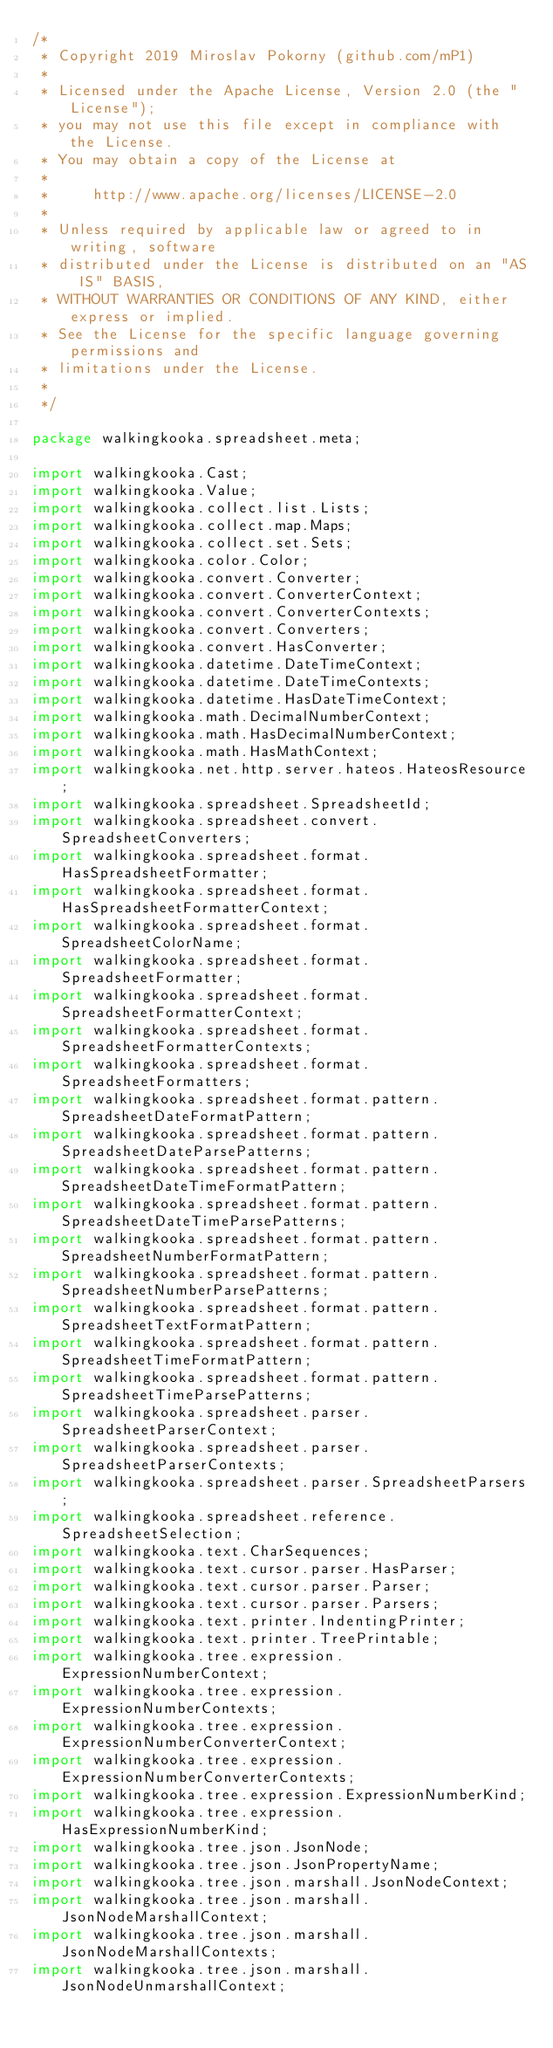<code> <loc_0><loc_0><loc_500><loc_500><_Java_>/*
 * Copyright 2019 Miroslav Pokorny (github.com/mP1)
 *
 * Licensed under the Apache License, Version 2.0 (the "License");
 * you may not use this file except in compliance with the License.
 * You may obtain a copy of the License at
 *
 *     http://www.apache.org/licenses/LICENSE-2.0
 *
 * Unless required by applicable law or agreed to in writing, software
 * distributed under the License is distributed on an "AS IS" BASIS,
 * WITHOUT WARRANTIES OR CONDITIONS OF ANY KIND, either express or implied.
 * See the License for the specific language governing permissions and
 * limitations under the License.
 *
 */

package walkingkooka.spreadsheet.meta;

import walkingkooka.Cast;
import walkingkooka.Value;
import walkingkooka.collect.list.Lists;
import walkingkooka.collect.map.Maps;
import walkingkooka.collect.set.Sets;
import walkingkooka.color.Color;
import walkingkooka.convert.Converter;
import walkingkooka.convert.ConverterContext;
import walkingkooka.convert.ConverterContexts;
import walkingkooka.convert.Converters;
import walkingkooka.convert.HasConverter;
import walkingkooka.datetime.DateTimeContext;
import walkingkooka.datetime.DateTimeContexts;
import walkingkooka.datetime.HasDateTimeContext;
import walkingkooka.math.DecimalNumberContext;
import walkingkooka.math.HasDecimalNumberContext;
import walkingkooka.math.HasMathContext;
import walkingkooka.net.http.server.hateos.HateosResource;
import walkingkooka.spreadsheet.SpreadsheetId;
import walkingkooka.spreadsheet.convert.SpreadsheetConverters;
import walkingkooka.spreadsheet.format.HasSpreadsheetFormatter;
import walkingkooka.spreadsheet.format.HasSpreadsheetFormatterContext;
import walkingkooka.spreadsheet.format.SpreadsheetColorName;
import walkingkooka.spreadsheet.format.SpreadsheetFormatter;
import walkingkooka.spreadsheet.format.SpreadsheetFormatterContext;
import walkingkooka.spreadsheet.format.SpreadsheetFormatterContexts;
import walkingkooka.spreadsheet.format.SpreadsheetFormatters;
import walkingkooka.spreadsheet.format.pattern.SpreadsheetDateFormatPattern;
import walkingkooka.spreadsheet.format.pattern.SpreadsheetDateParsePatterns;
import walkingkooka.spreadsheet.format.pattern.SpreadsheetDateTimeFormatPattern;
import walkingkooka.spreadsheet.format.pattern.SpreadsheetDateTimeParsePatterns;
import walkingkooka.spreadsheet.format.pattern.SpreadsheetNumberFormatPattern;
import walkingkooka.spreadsheet.format.pattern.SpreadsheetNumberParsePatterns;
import walkingkooka.spreadsheet.format.pattern.SpreadsheetTextFormatPattern;
import walkingkooka.spreadsheet.format.pattern.SpreadsheetTimeFormatPattern;
import walkingkooka.spreadsheet.format.pattern.SpreadsheetTimeParsePatterns;
import walkingkooka.spreadsheet.parser.SpreadsheetParserContext;
import walkingkooka.spreadsheet.parser.SpreadsheetParserContexts;
import walkingkooka.spreadsheet.parser.SpreadsheetParsers;
import walkingkooka.spreadsheet.reference.SpreadsheetSelection;
import walkingkooka.text.CharSequences;
import walkingkooka.text.cursor.parser.HasParser;
import walkingkooka.text.cursor.parser.Parser;
import walkingkooka.text.cursor.parser.Parsers;
import walkingkooka.text.printer.IndentingPrinter;
import walkingkooka.text.printer.TreePrintable;
import walkingkooka.tree.expression.ExpressionNumberContext;
import walkingkooka.tree.expression.ExpressionNumberContexts;
import walkingkooka.tree.expression.ExpressionNumberConverterContext;
import walkingkooka.tree.expression.ExpressionNumberConverterContexts;
import walkingkooka.tree.expression.ExpressionNumberKind;
import walkingkooka.tree.expression.HasExpressionNumberKind;
import walkingkooka.tree.json.JsonNode;
import walkingkooka.tree.json.JsonPropertyName;
import walkingkooka.tree.json.marshall.JsonNodeContext;
import walkingkooka.tree.json.marshall.JsonNodeMarshallContext;
import walkingkooka.tree.json.marshall.JsonNodeMarshallContexts;
import walkingkooka.tree.json.marshall.JsonNodeUnmarshallContext;</code> 